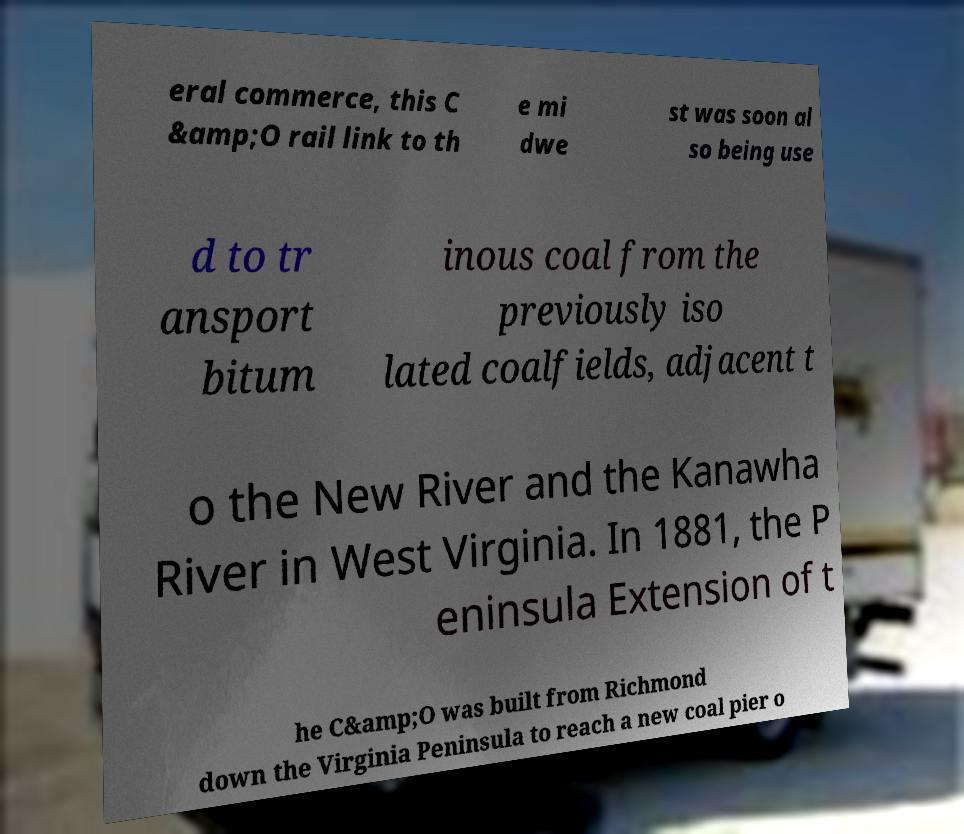Please read and relay the text visible in this image. What does it say? eral commerce, this C &amp;O rail link to th e mi dwe st was soon al so being use d to tr ansport bitum inous coal from the previously iso lated coalfields, adjacent t o the New River and the Kanawha River in West Virginia. In 1881, the P eninsula Extension of t he C&amp;O was built from Richmond down the Virginia Peninsula to reach a new coal pier o 